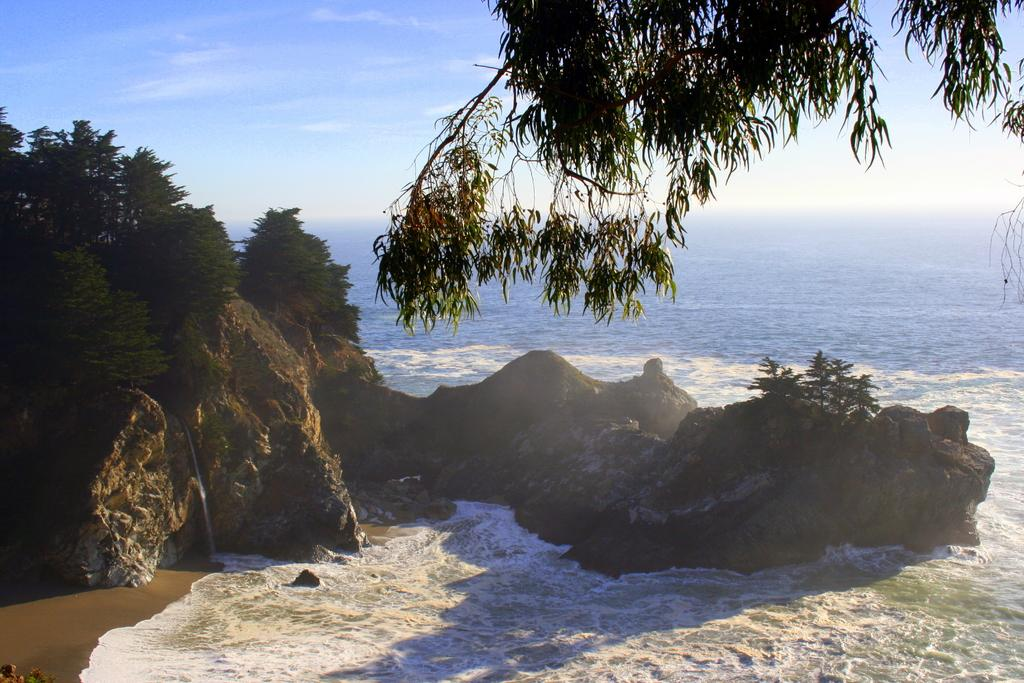What can be seen in the foreground of the picture? In the foreground of the picture, there are trees, a mountain, water, sand, and stems of a tree. Can you describe the water body in the middle of the picture? There is a water body in the middle of the picture, but its specific characteristics are not mentioned in the facts. What is visible in the background of the picture? In the background of the picture, there is sky visible. What type of nose can be seen on the tree stems in the image? There is no nose present on the tree stems in the image. What type of harmony is depicted in the image? The image does not depict any musical harmony or any other type of harmony. 